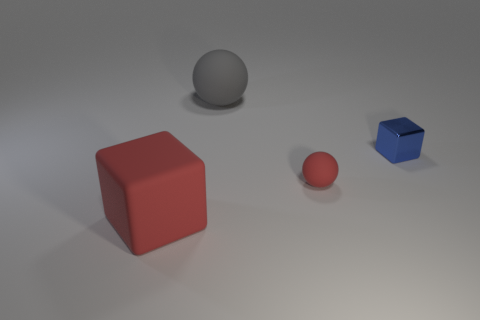The gray sphere has what size?
Make the answer very short. Large. The block in front of the small thing on the right side of the rubber ball that is in front of the shiny block is made of what material?
Offer a very short reply. Rubber. How many other objects are the same color as the big matte cube?
Your response must be concise. 1. How many gray things are either small rubber objects or large matte balls?
Give a very brief answer. 1. There is a big thing in front of the small red matte sphere; what is it made of?
Provide a succinct answer. Rubber. Does the sphere that is behind the shiny block have the same material as the small blue cube?
Make the answer very short. No. What is the shape of the large gray thing?
Ensure brevity in your answer.  Sphere. There is a large matte thing on the left side of the large thing that is behind the big red rubber thing; what number of gray balls are behind it?
Make the answer very short. 1. How many other things are there of the same material as the red block?
Ensure brevity in your answer.  2. There is a block that is the same size as the gray rubber ball; what is its material?
Your answer should be compact. Rubber. 